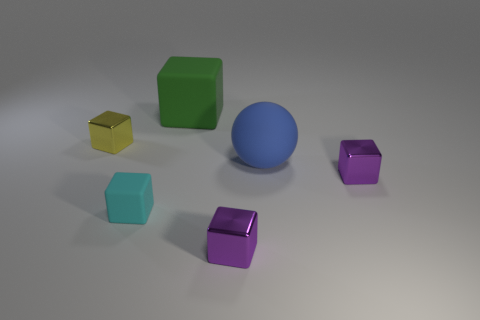Subtract 1 cubes. How many cubes are left? 4 Subtract all small cyan rubber cubes. How many cubes are left? 4 Subtract all cyan cubes. How many cubes are left? 4 Subtract all blue blocks. Subtract all cyan balls. How many blocks are left? 5 Add 1 gray rubber things. How many objects exist? 7 Subtract all balls. How many objects are left? 5 Subtract 0 yellow balls. How many objects are left? 6 Subtract all large rubber blocks. Subtract all large blue rubber spheres. How many objects are left? 4 Add 3 metallic cubes. How many metallic cubes are left? 6 Add 6 big rubber cubes. How many big rubber cubes exist? 7 